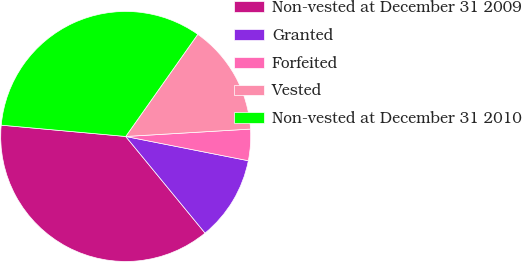<chart> <loc_0><loc_0><loc_500><loc_500><pie_chart><fcel>Non-vested at December 31 2009<fcel>Granted<fcel>Forfeited<fcel>Vested<fcel>Non-vested at December 31 2010<nl><fcel>37.39%<fcel>10.95%<fcel>4.05%<fcel>14.28%<fcel>33.34%<nl></chart> 